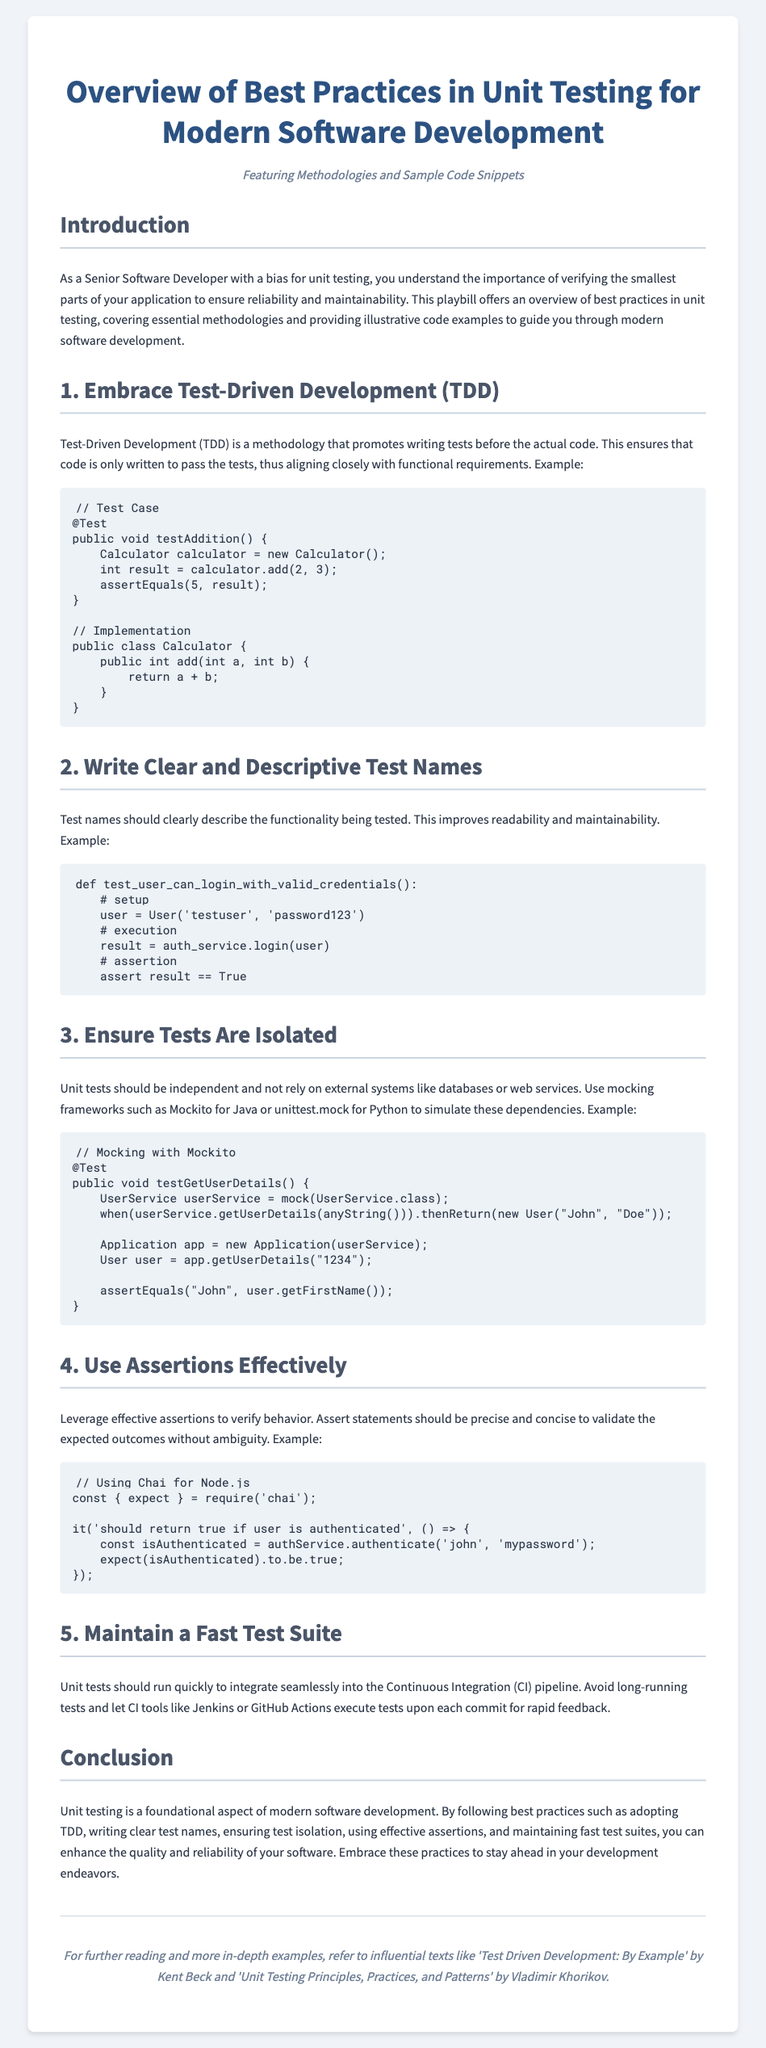What is the title of the document? The title of the document is prominently displayed at the top.
Answer: Overview of Best Practices in Unit Testing for Modern Software Development What methodology is emphasized in the playbill? The playbill specifically highlights one methodology as the first point in the list.
Answer: Test-Driven Development What should test names describe? The playbill mentions specifically what test names should clearly describe to improve readability.
Answer: Functionality being tested What is a recommended framework for mocking in Java? The playbill suggests a specific framework for mocking dependencies in Java unit tests.
Answer: Mockito What assertion library is referenced for Node.js? The playbill mentions a library that is used for assertions in Node.js examples.
Answer: Chai How many key best practices are outlined in the document? The document lists a specific number of best practices to follow.
Answer: Five What should unit tests maintain to integrate into CI? The playbill advises what characteristic should be preserved by the unit tests for integration into CI processes.
Answer: Fast testing Who authored 'Test Driven Development: By Example'? The document cites a specific author of a influential text in unit testing best practices.
Answer: Kent Beck What is suggested to improve the maintainability of tests? The playbill discusses qualities that should be focused on to enhance the maintainability of tests.
Answer: Clear and descriptive test names 